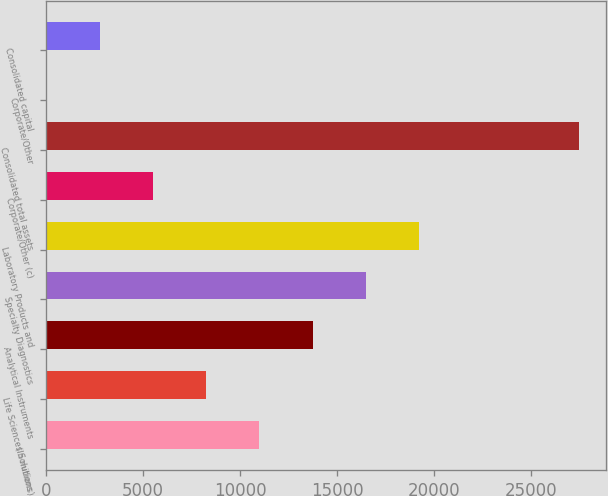<chart> <loc_0><loc_0><loc_500><loc_500><bar_chart><fcel>(In millions)<fcel>Life Sciences Solutions<fcel>Analytical Instruments<fcel>Specialty Diagnostics<fcel>Laboratory Products and<fcel>Corporate/Other (c)<fcel>Consolidated total assets<fcel>Corporate/Other<fcel>Consolidated capital<nl><fcel>10999.4<fcel>8258.58<fcel>13740.3<fcel>16481.2<fcel>19222<fcel>5517.72<fcel>27444.6<fcel>36<fcel>2776.86<nl></chart> 